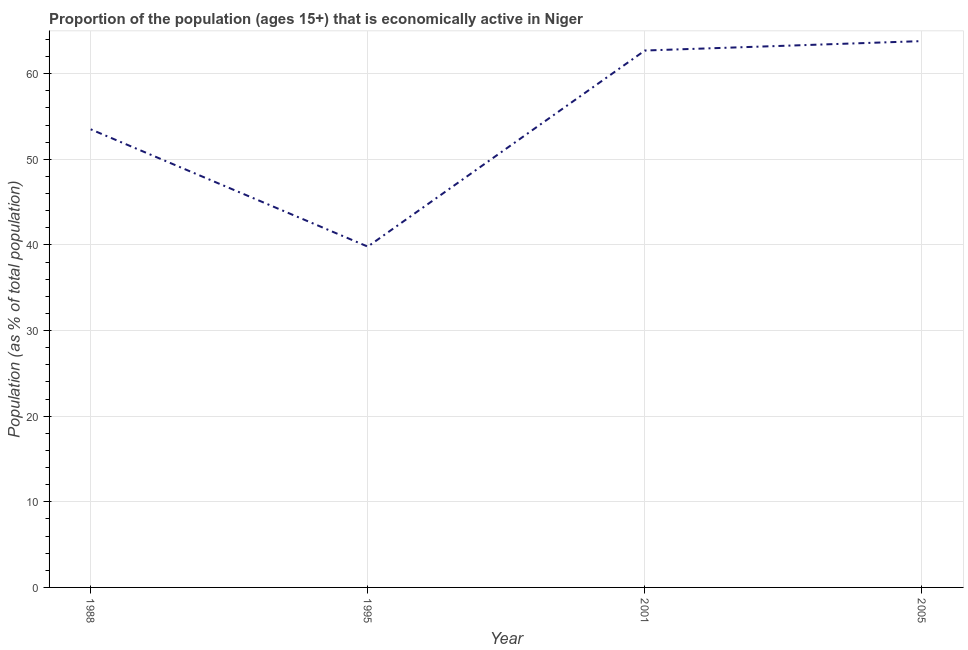What is the percentage of economically active population in 2005?
Ensure brevity in your answer.  63.8. Across all years, what is the maximum percentage of economically active population?
Offer a terse response. 63.8. Across all years, what is the minimum percentage of economically active population?
Provide a succinct answer. 39.8. In which year was the percentage of economically active population maximum?
Your answer should be very brief. 2005. What is the sum of the percentage of economically active population?
Provide a succinct answer. 219.8. What is the average percentage of economically active population per year?
Ensure brevity in your answer.  54.95. What is the median percentage of economically active population?
Give a very brief answer. 58.1. Do a majority of the years between 1995 and 2005 (inclusive) have percentage of economically active population greater than 42 %?
Offer a terse response. Yes. What is the ratio of the percentage of economically active population in 1988 to that in 1995?
Provide a short and direct response. 1.34. What is the difference between the highest and the second highest percentage of economically active population?
Offer a very short reply. 1.1. Is the sum of the percentage of economically active population in 1995 and 2001 greater than the maximum percentage of economically active population across all years?
Your answer should be very brief. Yes. What is the difference between two consecutive major ticks on the Y-axis?
Provide a short and direct response. 10. What is the title of the graph?
Provide a short and direct response. Proportion of the population (ages 15+) that is economically active in Niger. What is the label or title of the X-axis?
Provide a short and direct response. Year. What is the label or title of the Y-axis?
Ensure brevity in your answer.  Population (as % of total population). What is the Population (as % of total population) in 1988?
Keep it short and to the point. 53.5. What is the Population (as % of total population) of 1995?
Your answer should be very brief. 39.8. What is the Population (as % of total population) of 2001?
Keep it short and to the point. 62.7. What is the Population (as % of total population) in 2005?
Keep it short and to the point. 63.8. What is the difference between the Population (as % of total population) in 1988 and 1995?
Offer a terse response. 13.7. What is the difference between the Population (as % of total population) in 1988 and 2001?
Offer a terse response. -9.2. What is the difference between the Population (as % of total population) in 1988 and 2005?
Give a very brief answer. -10.3. What is the difference between the Population (as % of total population) in 1995 and 2001?
Provide a short and direct response. -22.9. What is the difference between the Population (as % of total population) in 1995 and 2005?
Give a very brief answer. -24. What is the ratio of the Population (as % of total population) in 1988 to that in 1995?
Provide a short and direct response. 1.34. What is the ratio of the Population (as % of total population) in 1988 to that in 2001?
Provide a succinct answer. 0.85. What is the ratio of the Population (as % of total population) in 1988 to that in 2005?
Your answer should be very brief. 0.84. What is the ratio of the Population (as % of total population) in 1995 to that in 2001?
Provide a succinct answer. 0.64. What is the ratio of the Population (as % of total population) in 1995 to that in 2005?
Make the answer very short. 0.62. What is the ratio of the Population (as % of total population) in 2001 to that in 2005?
Your answer should be very brief. 0.98. 